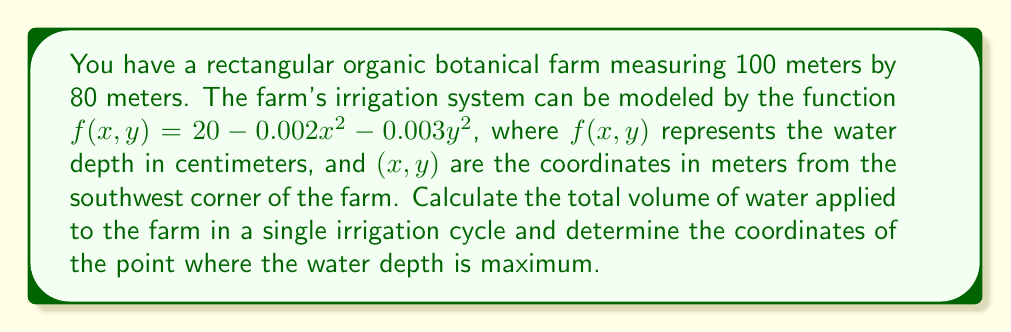Could you help me with this problem? To solve this problem, we'll use multivariable calculus techniques:

1. Calculate the total volume of water:
   We need to integrate the function $f(x,y)$ over the entire area of the farm.

   $$V = \int_0^{80} \int_0^{100} (20 - 0.002x^2 - 0.003y^2) \, dx \, dy$$

   Integrating with respect to x:
   $$V = \int_0^{80} \left[20x - \frac{0.002x^3}{3} - 0.003y^2x\right]_0^{100} \, dy$$
   
   $$V = \int_0^{80} \left(2000 - \frac{200000}{3} - 300y^2\right) \, dy$$

   Integrating with respect to y:
   $$V = \left[2000y - \frac{200000y}{3} - 100y^3\right]_0^{80}$$

   $$V = 160000 - 5333333.33 - 51200000 = 93666666.67 \text{ cm}^3 = 93.67 \text{ m}^3$$

2. Find the maximum water depth:
   To find the maximum, we need to calculate the partial derivatives and set them to zero:

   $$\frac{\partial f}{\partial x} = -0.004x = 0$$
   $$\frac{\partial f}{\partial y} = -0.006y = 0$$

   Solving these equations:
   $x = 0$ and $y = 0$

   The second partial derivatives are negative, confirming this is a maximum:
   $$\frac{\partial^2 f}{\partial x^2} = -0.004 < 0$$
   $$\frac{\partial^2 f}{\partial y^2} = -0.006 < 0$$

   The maximum occurs at (0, 0), which corresponds to the southwest corner of the farm.
   The maximum water depth is:
   $$f(0,0) = 20 - 0.002(0)^2 - 0.003(0)^2 = 20 \text{ cm}$$
Answer: 93.67 m³; (0, 0) 